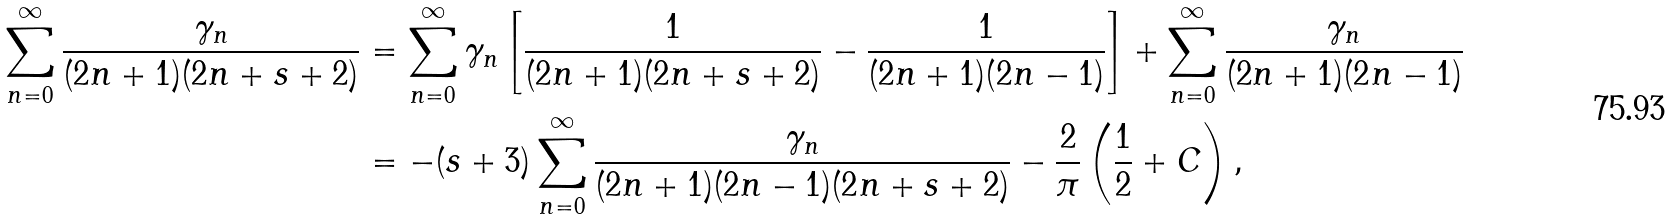<formula> <loc_0><loc_0><loc_500><loc_500>\sum _ { n = 0 } ^ { \infty } { \frac { \gamma _ { n } } { ( 2 n + 1 ) ( 2 n + s + 2 ) } } & = \sum _ { n = 0 } ^ { \infty } { \gamma _ { n } \left [ \frac { 1 } { ( 2 n + 1 ) ( 2 n + s + 2 ) } - \frac { 1 } { ( 2 n + 1 ) ( 2 n - 1 ) } \right ] } + \sum _ { n = 0 } ^ { \infty } { \frac { \gamma _ { n } } { ( 2 n + 1 ) ( 2 n - 1 ) } } \\ & = - ( s + 3 ) \sum _ { n = 0 } ^ { \infty } { \frac { \gamma _ { n } } { ( 2 n + 1 ) ( 2 n - 1 ) ( 2 n + s + 2 ) } } - \frac { 2 } { \pi } \left ( \frac { 1 } { 2 } + C \right ) ,</formula> 